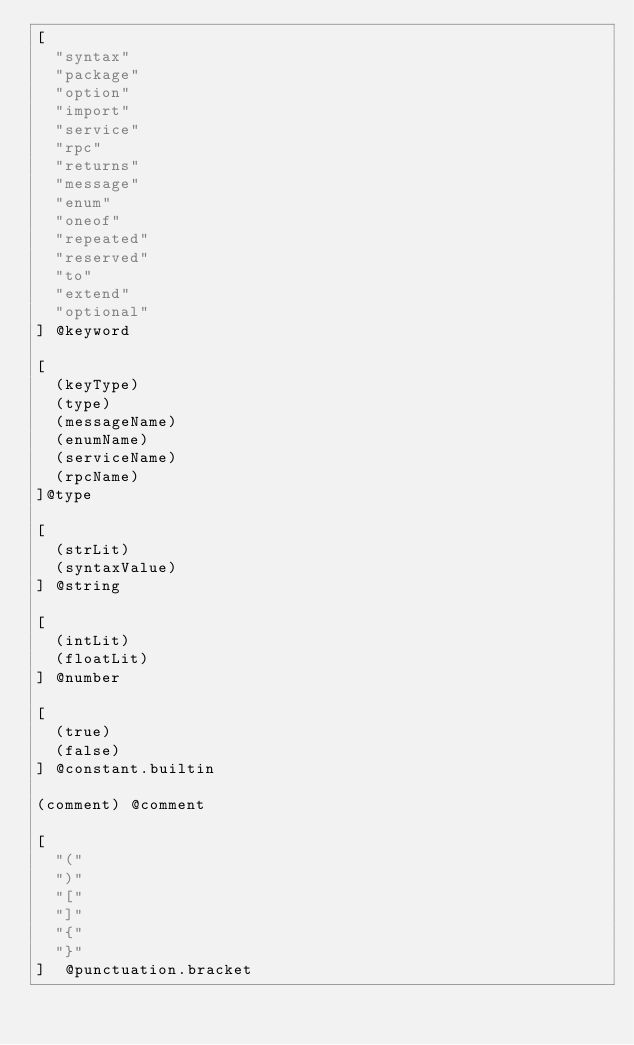<code> <loc_0><loc_0><loc_500><loc_500><_Scheme_>[
  "syntax"
  "package"
  "option"
  "import"
  "service"
  "rpc"
  "returns"
  "message"
  "enum"
  "oneof"
  "repeated"
  "reserved"
  "to"
  "extend"
  "optional"
] @keyword

[
  (keyType)
  (type)
  (messageName)
  (enumName)
  (serviceName)
  (rpcName)
]@type

[
  (strLit)
  (syntaxValue)
] @string

[
  (intLit)
  (floatLit)
] @number

[
  (true)
  (false)
] @constant.builtin

(comment) @comment

[
  "("
  ")"
  "["
  "]"
  "{"
  "}"
]  @punctuation.bracket

</code> 